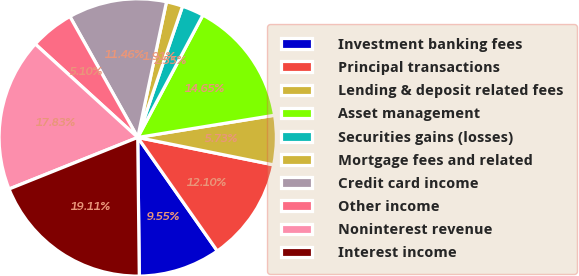Convert chart. <chart><loc_0><loc_0><loc_500><loc_500><pie_chart><fcel>Investment banking fees<fcel>Principal transactions<fcel>Lending & deposit related fees<fcel>Asset management<fcel>Securities gains (losses)<fcel>Mortgage fees and related<fcel>Credit card income<fcel>Other income<fcel>Noninterest revenue<fcel>Interest income<nl><fcel>9.55%<fcel>12.1%<fcel>5.73%<fcel>14.65%<fcel>2.55%<fcel>1.91%<fcel>11.46%<fcel>5.1%<fcel>17.83%<fcel>19.11%<nl></chart> 